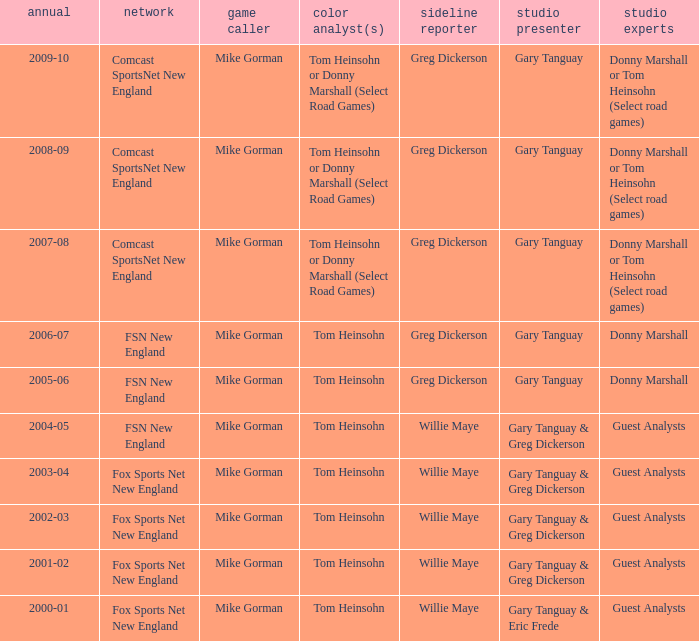WHich Studio analysts has a Studio host of gary tanguay in 2009-10? Donny Marshall or Tom Heinsohn (Select road games). 